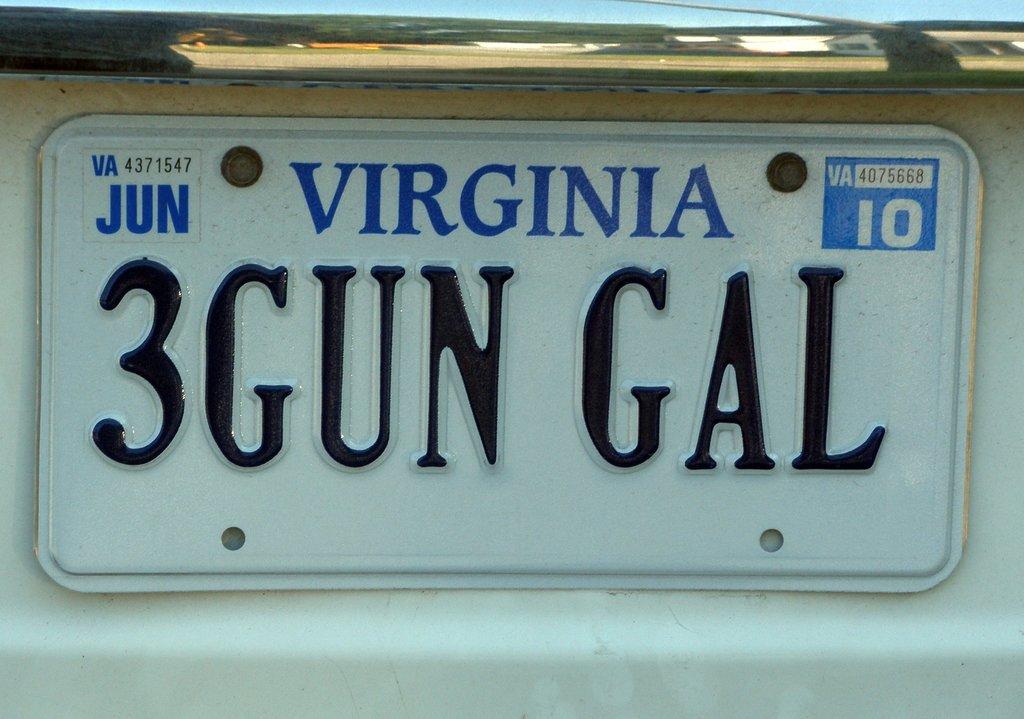What state is the license plate from?
Offer a terse response. Virginia. What month was the plate issued?
Your answer should be compact. June. 